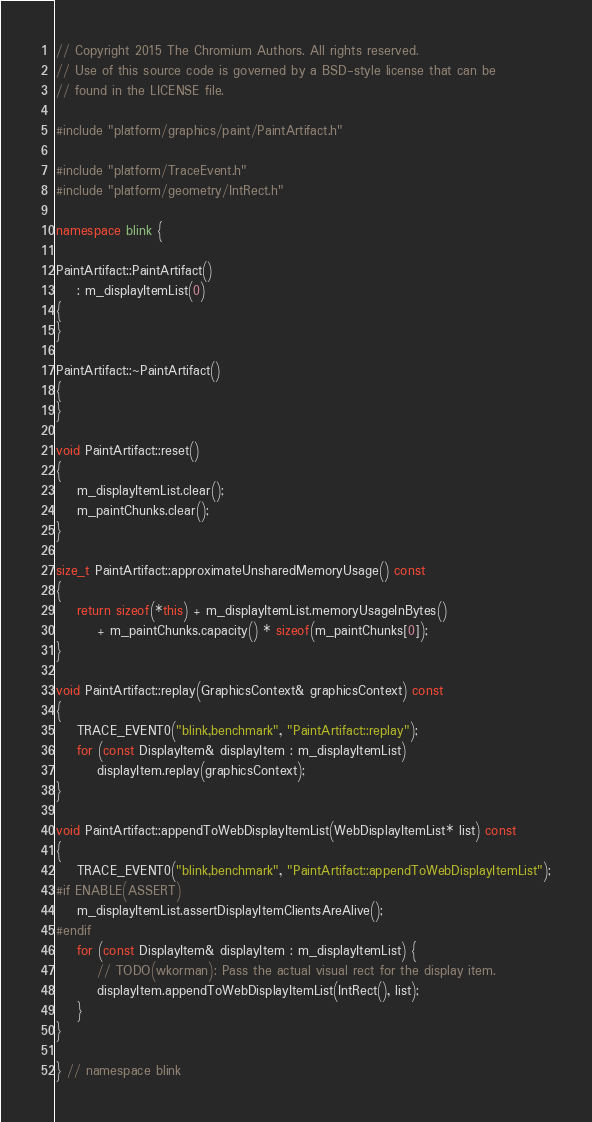Convert code to text. <code><loc_0><loc_0><loc_500><loc_500><_C++_>// Copyright 2015 The Chromium Authors. All rights reserved.
// Use of this source code is governed by a BSD-style license that can be
// found in the LICENSE file.

#include "platform/graphics/paint/PaintArtifact.h"

#include "platform/TraceEvent.h"
#include "platform/geometry/IntRect.h"

namespace blink {

PaintArtifact::PaintArtifact()
    : m_displayItemList(0)
{
}

PaintArtifact::~PaintArtifact()
{
}

void PaintArtifact::reset()
{
    m_displayItemList.clear();
    m_paintChunks.clear();
}

size_t PaintArtifact::approximateUnsharedMemoryUsage() const
{
    return sizeof(*this) + m_displayItemList.memoryUsageInBytes()
        + m_paintChunks.capacity() * sizeof(m_paintChunks[0]);
}

void PaintArtifact::replay(GraphicsContext& graphicsContext) const
{
    TRACE_EVENT0("blink,benchmark", "PaintArtifact::replay");
    for (const DisplayItem& displayItem : m_displayItemList)
        displayItem.replay(graphicsContext);
}

void PaintArtifact::appendToWebDisplayItemList(WebDisplayItemList* list) const
{
    TRACE_EVENT0("blink,benchmark", "PaintArtifact::appendToWebDisplayItemList");
#if ENABLE(ASSERT)
    m_displayItemList.assertDisplayItemClientsAreAlive();
#endif
    for (const DisplayItem& displayItem : m_displayItemList) {
        // TODO(wkorman): Pass the actual visual rect for the display item.
        displayItem.appendToWebDisplayItemList(IntRect(), list);
    }
}

} // namespace blink
</code> 